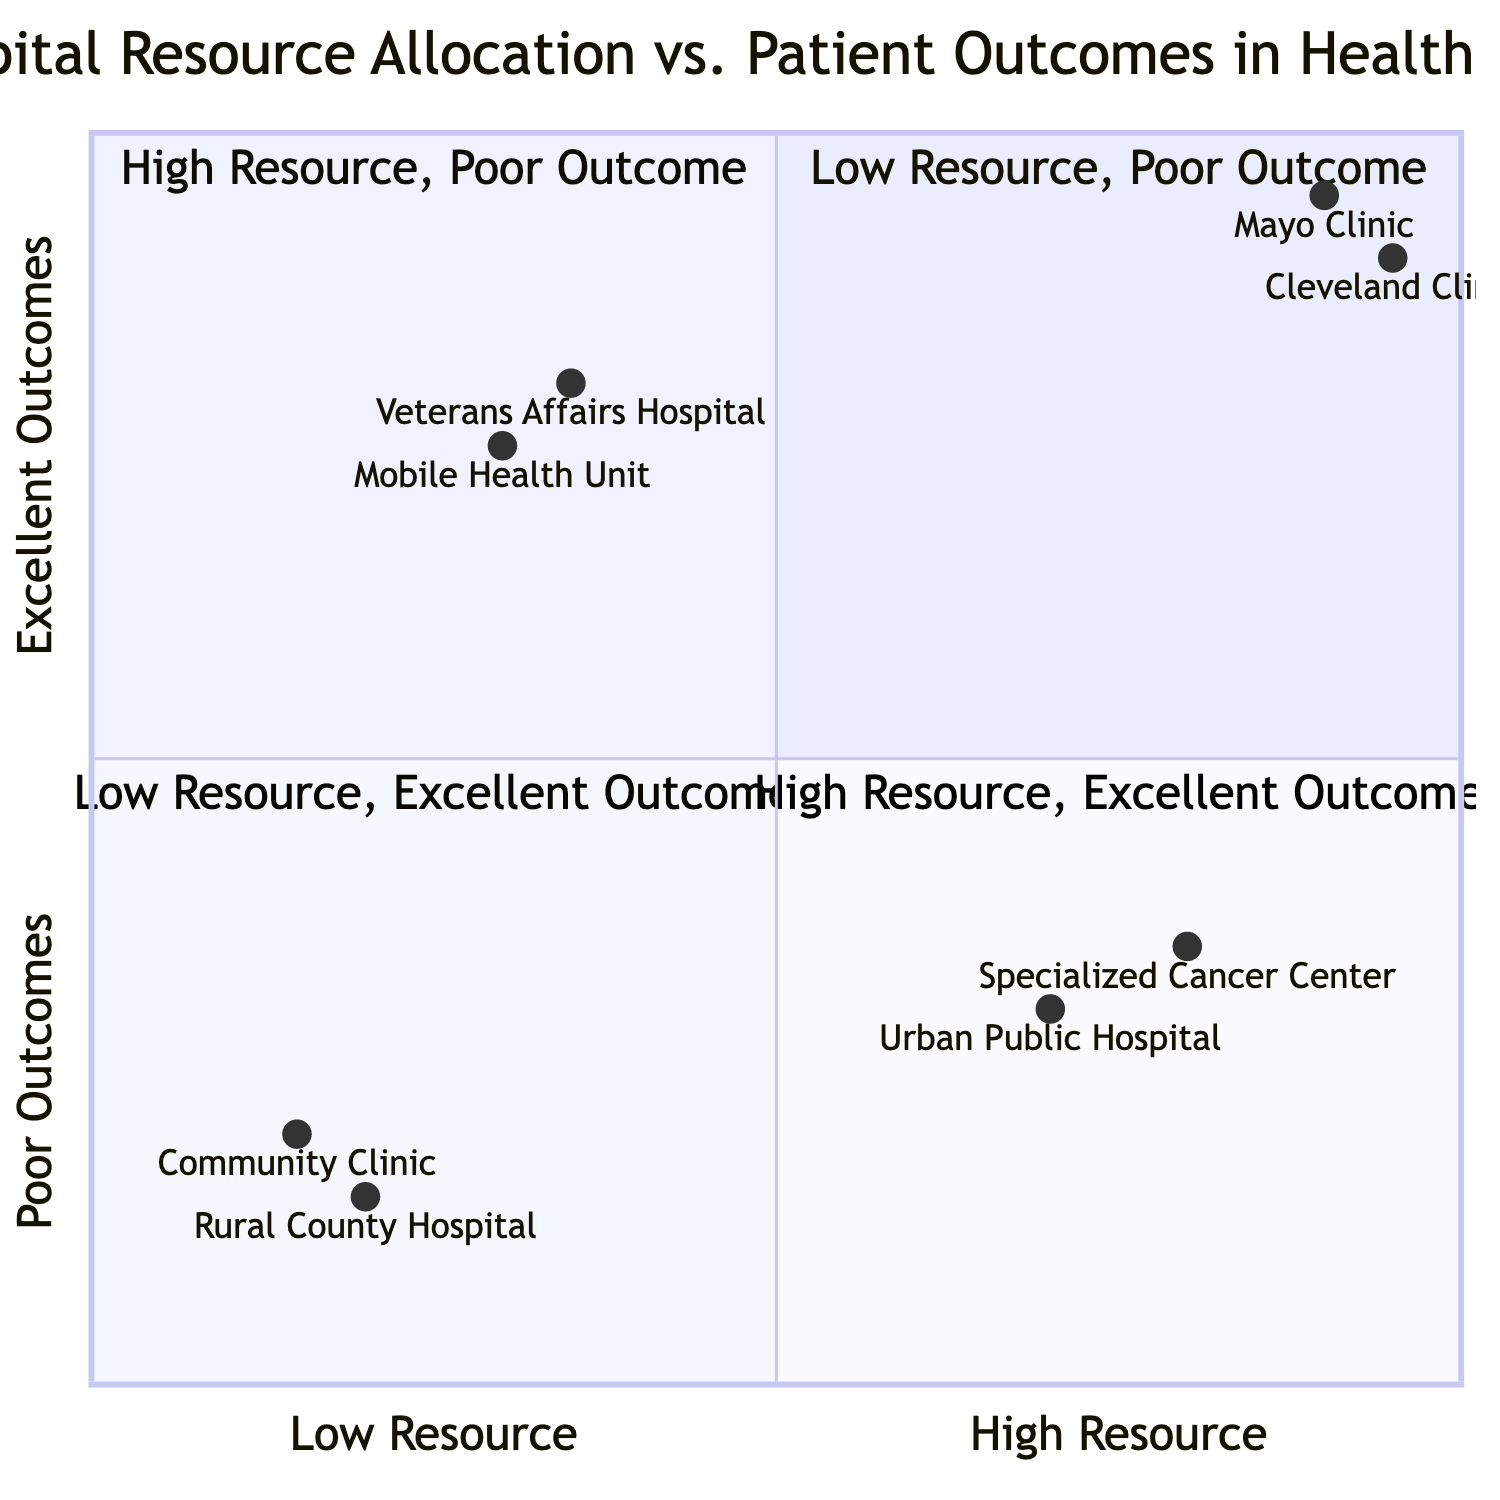What hospitals fall under the "High Resource, Excellent Outcome" quadrant? The "High Resource, Excellent Outcome" quadrant contains hospitals that are characterized by high levels of resources and excellent patient outcomes. Based on the diagram data, the identified hospitals in this quadrant are the Mayo Clinic and the Cleveland Clinic.
Answer: Mayo Clinic, Cleveland Clinic Which hospital has limited funding and basic infrastructure but high-quality management of chronic illnesses? The description in the "Low Resource, Excellent Outcome" quadrant specifies the Veterans Affairs Hospital as having limited funding and basic infrastructure while maintaining high-quality management of chronic illnesses, which indicates an excellent patient outcome despite lower resource allocation.
Answer: Veterans Affairs Hospital How many hospitals are categorized in the "Low Resource, Poor Outcome" quadrant? The "Low Resource, Poor Outcome" quadrant lists two hospitals: the Rural County Hospital and the Community Clinic. Therefore, the total count of hospitals in this quadrant is two.
Answer: 2 What is the patient outcome rating of the Urban Public Hospital? According to the data provided in the "High Resource, Poor Outcome" quadrant, the Urban Public Hospital has a patient outcome rating of 'Poor' as indicated by its coordinates (0.7, 0.3) which categorizes it under this quadrant based on its balance of resource allocation and patient outcome.
Answer: Poor Is there a hospital that has 'Effective preventive care' with limited medical staff? The diagram indicates that the Mobile Health Unit falls under the "Low Resource, Excellent Outcome" quadrant, characterized by limited medical staff but achieving effective preventive care and high patient satisfaction. Hence, this hospital fits the mentioned criteria accurately.
Answer: Mobile Health Unit Which quadrant contains hospitals with advanced treatments but inconsistent results? The "High Resource, Poor Outcome" quadrant includes the Specialized Cancer Center, which is known for having advanced technology and specialized treatments but reports inconsistent patient outcomes as per the description of the quadrant.
Answer: High Resource, Poor Outcome What is the range of patient outcomes for hospitals in the "High Resource, Excellent Outcome" quadrant? The patient outcomes for the hospitals categorized under the "High Resource, Excellent Outcome" quadrant, such as the Mayo Clinic and Cleveland Clinic, are described as 'High survival rates' and 'Exceptional patient satisfaction,' indicating a range of outcomes between high and excellent.
Answer: High to Excellent What resources does the Mobile Health Unit have? According to the "Low Resource, Excellent Outcome" quadrant, the Mobile Health Unit has limited medical staff and basic treatment capability, which positions it to deliver effective preventive care. Therefore, the resources described highlight a basic level of provision that supports excellent patient outcomes.
Answer: Limited medical staff, basic treatment capability 